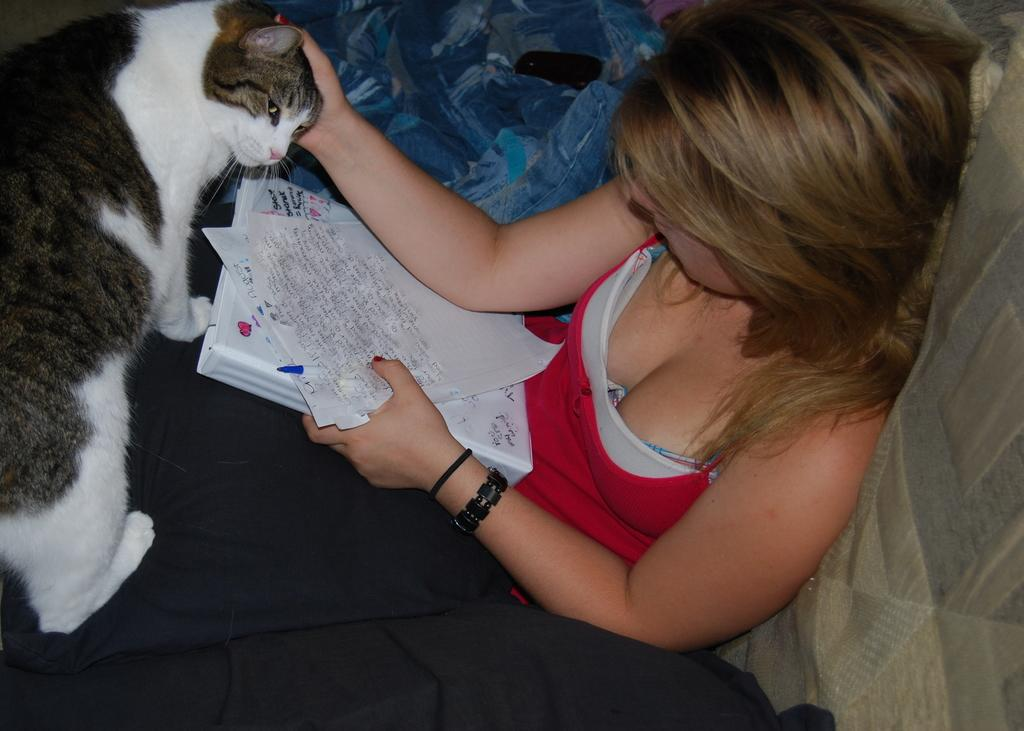Who is the main subject in the image? There is a woman in the image. What is the woman doing in the image? The woman is sitting on a couch and holding papers, a book, and a pen. Is there any interaction between the woman and an animal in the image? Yes, the woman is touching a cat in the image. What type of flame can be seen on the woman's hand in the image? There is no flame present on the woman's hand or anywhere else in the image. 